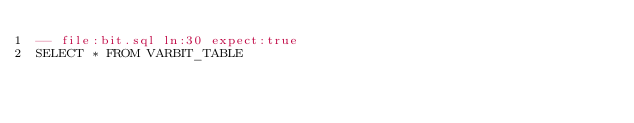Convert code to text. <code><loc_0><loc_0><loc_500><loc_500><_SQL_>-- file:bit.sql ln:30 expect:true
SELECT * FROM VARBIT_TABLE
</code> 